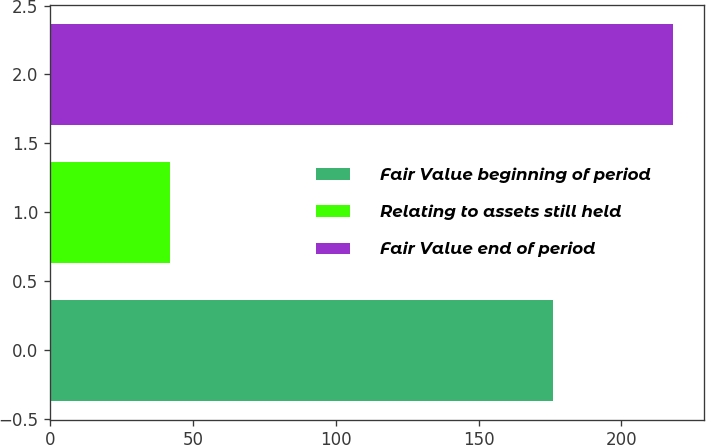Convert chart. <chart><loc_0><loc_0><loc_500><loc_500><bar_chart><fcel>Fair Value beginning of period<fcel>Relating to assets still held<fcel>Fair Value end of period<nl><fcel>176<fcel>42<fcel>218<nl></chart> 